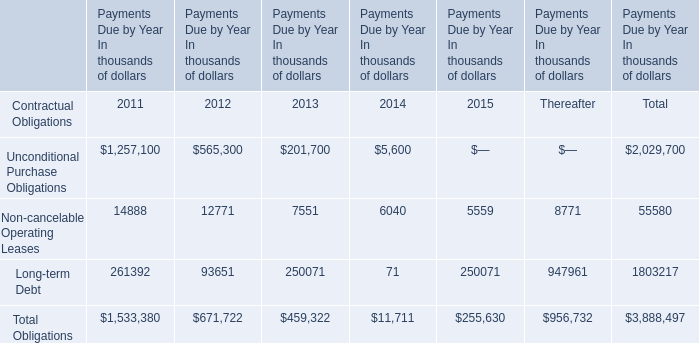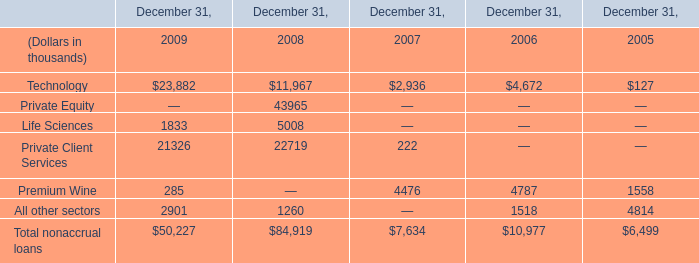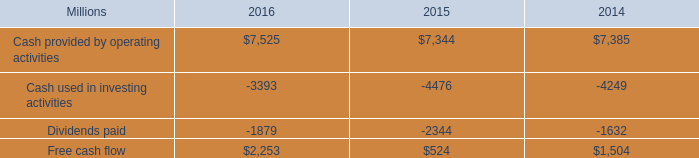What was the total amount of the Life Sciences in the years where Technology greater than 10000?? (in thousand) 
Computations: (1833 + 5008)
Answer: 6841.0. 